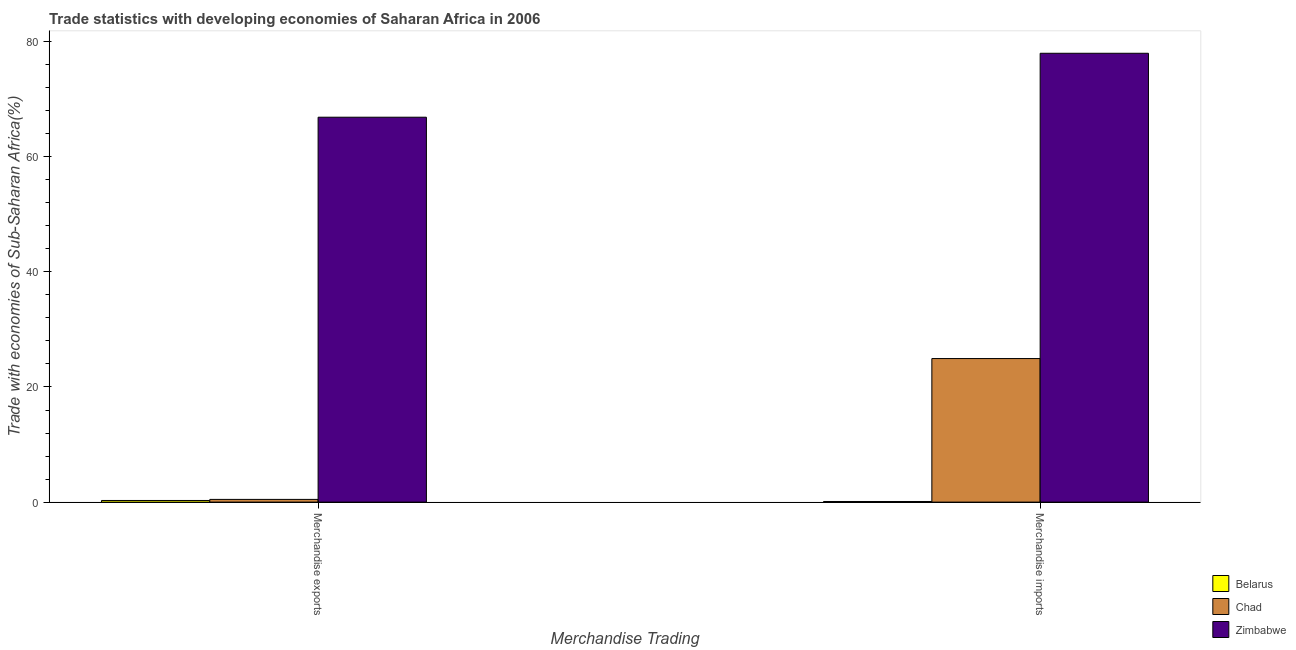How many bars are there on the 1st tick from the left?
Provide a short and direct response. 3. What is the merchandise imports in Zimbabwe?
Provide a succinct answer. 77.96. Across all countries, what is the maximum merchandise exports?
Provide a short and direct response. 66.85. Across all countries, what is the minimum merchandise imports?
Give a very brief answer. 0.11. In which country was the merchandise imports maximum?
Provide a short and direct response. Zimbabwe. In which country was the merchandise imports minimum?
Offer a very short reply. Belarus. What is the total merchandise imports in the graph?
Your answer should be very brief. 103. What is the difference between the merchandise imports in Belarus and that in Chad?
Offer a very short reply. -24.83. What is the difference between the merchandise exports in Chad and the merchandise imports in Zimbabwe?
Make the answer very short. -77.48. What is the average merchandise imports per country?
Offer a terse response. 34.33. What is the difference between the merchandise exports and merchandise imports in Chad?
Your answer should be very brief. -24.46. What is the ratio of the merchandise imports in Belarus to that in Chad?
Offer a very short reply. 0. Is the merchandise imports in Belarus less than that in Chad?
Your answer should be compact. Yes. In how many countries, is the merchandise exports greater than the average merchandise exports taken over all countries?
Make the answer very short. 1. What does the 2nd bar from the left in Merchandise exports represents?
Ensure brevity in your answer.  Chad. What does the 1st bar from the right in Merchandise exports represents?
Your answer should be compact. Zimbabwe. How many bars are there?
Your response must be concise. 6. Are all the bars in the graph horizontal?
Provide a succinct answer. No. How many countries are there in the graph?
Offer a terse response. 3. Does the graph contain any zero values?
Your answer should be very brief. No. Does the graph contain grids?
Make the answer very short. No. Where does the legend appear in the graph?
Your answer should be compact. Bottom right. How many legend labels are there?
Your answer should be very brief. 3. What is the title of the graph?
Make the answer very short. Trade statistics with developing economies of Saharan Africa in 2006. What is the label or title of the X-axis?
Give a very brief answer. Merchandise Trading. What is the label or title of the Y-axis?
Provide a short and direct response. Trade with economies of Sub-Saharan Africa(%). What is the Trade with economies of Sub-Saharan Africa(%) of Belarus in Merchandise exports?
Make the answer very short. 0.29. What is the Trade with economies of Sub-Saharan Africa(%) in Chad in Merchandise exports?
Your answer should be compact. 0.47. What is the Trade with economies of Sub-Saharan Africa(%) in Zimbabwe in Merchandise exports?
Ensure brevity in your answer.  66.85. What is the Trade with economies of Sub-Saharan Africa(%) of Belarus in Merchandise imports?
Offer a very short reply. 0.11. What is the Trade with economies of Sub-Saharan Africa(%) in Chad in Merchandise imports?
Offer a terse response. 24.93. What is the Trade with economies of Sub-Saharan Africa(%) of Zimbabwe in Merchandise imports?
Your response must be concise. 77.96. Across all Merchandise Trading, what is the maximum Trade with economies of Sub-Saharan Africa(%) of Belarus?
Offer a terse response. 0.29. Across all Merchandise Trading, what is the maximum Trade with economies of Sub-Saharan Africa(%) of Chad?
Give a very brief answer. 24.93. Across all Merchandise Trading, what is the maximum Trade with economies of Sub-Saharan Africa(%) in Zimbabwe?
Provide a short and direct response. 77.96. Across all Merchandise Trading, what is the minimum Trade with economies of Sub-Saharan Africa(%) of Belarus?
Ensure brevity in your answer.  0.11. Across all Merchandise Trading, what is the minimum Trade with economies of Sub-Saharan Africa(%) in Chad?
Ensure brevity in your answer.  0.47. Across all Merchandise Trading, what is the minimum Trade with economies of Sub-Saharan Africa(%) in Zimbabwe?
Provide a short and direct response. 66.85. What is the total Trade with economies of Sub-Saharan Africa(%) in Belarus in the graph?
Make the answer very short. 0.39. What is the total Trade with economies of Sub-Saharan Africa(%) in Chad in the graph?
Provide a succinct answer. 25.41. What is the total Trade with economies of Sub-Saharan Africa(%) of Zimbabwe in the graph?
Offer a very short reply. 144.81. What is the difference between the Trade with economies of Sub-Saharan Africa(%) in Belarus in Merchandise exports and that in Merchandise imports?
Ensure brevity in your answer.  0.18. What is the difference between the Trade with economies of Sub-Saharan Africa(%) in Chad in Merchandise exports and that in Merchandise imports?
Make the answer very short. -24.46. What is the difference between the Trade with economies of Sub-Saharan Africa(%) in Zimbabwe in Merchandise exports and that in Merchandise imports?
Give a very brief answer. -11.11. What is the difference between the Trade with economies of Sub-Saharan Africa(%) of Belarus in Merchandise exports and the Trade with economies of Sub-Saharan Africa(%) of Chad in Merchandise imports?
Your answer should be compact. -24.65. What is the difference between the Trade with economies of Sub-Saharan Africa(%) in Belarus in Merchandise exports and the Trade with economies of Sub-Saharan Africa(%) in Zimbabwe in Merchandise imports?
Provide a succinct answer. -77.67. What is the difference between the Trade with economies of Sub-Saharan Africa(%) in Chad in Merchandise exports and the Trade with economies of Sub-Saharan Africa(%) in Zimbabwe in Merchandise imports?
Ensure brevity in your answer.  -77.48. What is the average Trade with economies of Sub-Saharan Africa(%) of Belarus per Merchandise Trading?
Offer a terse response. 0.2. What is the average Trade with economies of Sub-Saharan Africa(%) of Chad per Merchandise Trading?
Provide a short and direct response. 12.7. What is the average Trade with economies of Sub-Saharan Africa(%) of Zimbabwe per Merchandise Trading?
Make the answer very short. 72.4. What is the difference between the Trade with economies of Sub-Saharan Africa(%) in Belarus and Trade with economies of Sub-Saharan Africa(%) in Chad in Merchandise exports?
Offer a terse response. -0.19. What is the difference between the Trade with economies of Sub-Saharan Africa(%) in Belarus and Trade with economies of Sub-Saharan Africa(%) in Zimbabwe in Merchandise exports?
Your answer should be compact. -66.57. What is the difference between the Trade with economies of Sub-Saharan Africa(%) of Chad and Trade with economies of Sub-Saharan Africa(%) of Zimbabwe in Merchandise exports?
Your answer should be very brief. -66.38. What is the difference between the Trade with economies of Sub-Saharan Africa(%) in Belarus and Trade with economies of Sub-Saharan Africa(%) in Chad in Merchandise imports?
Offer a terse response. -24.83. What is the difference between the Trade with economies of Sub-Saharan Africa(%) of Belarus and Trade with economies of Sub-Saharan Africa(%) of Zimbabwe in Merchandise imports?
Provide a succinct answer. -77.85. What is the difference between the Trade with economies of Sub-Saharan Africa(%) of Chad and Trade with economies of Sub-Saharan Africa(%) of Zimbabwe in Merchandise imports?
Offer a terse response. -53.02. What is the ratio of the Trade with economies of Sub-Saharan Africa(%) of Belarus in Merchandise exports to that in Merchandise imports?
Provide a short and direct response. 2.63. What is the ratio of the Trade with economies of Sub-Saharan Africa(%) of Chad in Merchandise exports to that in Merchandise imports?
Provide a succinct answer. 0.02. What is the ratio of the Trade with economies of Sub-Saharan Africa(%) of Zimbabwe in Merchandise exports to that in Merchandise imports?
Your response must be concise. 0.86. What is the difference between the highest and the second highest Trade with economies of Sub-Saharan Africa(%) of Belarus?
Ensure brevity in your answer.  0.18. What is the difference between the highest and the second highest Trade with economies of Sub-Saharan Africa(%) of Chad?
Your answer should be compact. 24.46. What is the difference between the highest and the second highest Trade with economies of Sub-Saharan Africa(%) in Zimbabwe?
Provide a succinct answer. 11.11. What is the difference between the highest and the lowest Trade with economies of Sub-Saharan Africa(%) in Belarus?
Provide a succinct answer. 0.18. What is the difference between the highest and the lowest Trade with economies of Sub-Saharan Africa(%) of Chad?
Provide a succinct answer. 24.46. What is the difference between the highest and the lowest Trade with economies of Sub-Saharan Africa(%) of Zimbabwe?
Keep it short and to the point. 11.11. 